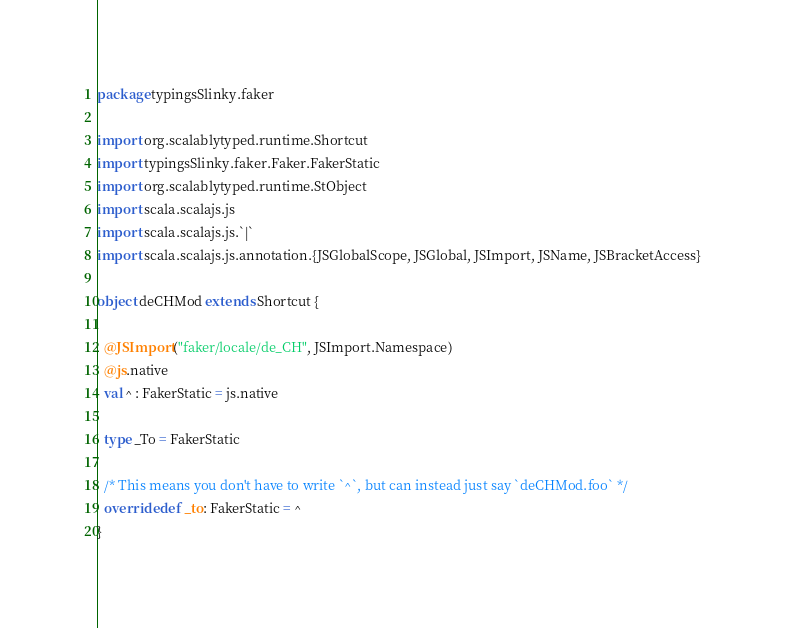Convert code to text. <code><loc_0><loc_0><loc_500><loc_500><_Scala_>package typingsSlinky.faker

import org.scalablytyped.runtime.Shortcut
import typingsSlinky.faker.Faker.FakerStatic
import org.scalablytyped.runtime.StObject
import scala.scalajs.js
import scala.scalajs.js.`|`
import scala.scalajs.js.annotation.{JSGlobalScope, JSGlobal, JSImport, JSName, JSBracketAccess}

object deCHMod extends Shortcut {
  
  @JSImport("faker/locale/de_CH", JSImport.Namespace)
  @js.native
  val ^ : FakerStatic = js.native
  
  type _To = FakerStatic
  
  /* This means you don't have to write `^`, but can instead just say `deCHMod.foo` */
  override def _to: FakerStatic = ^
}
</code> 